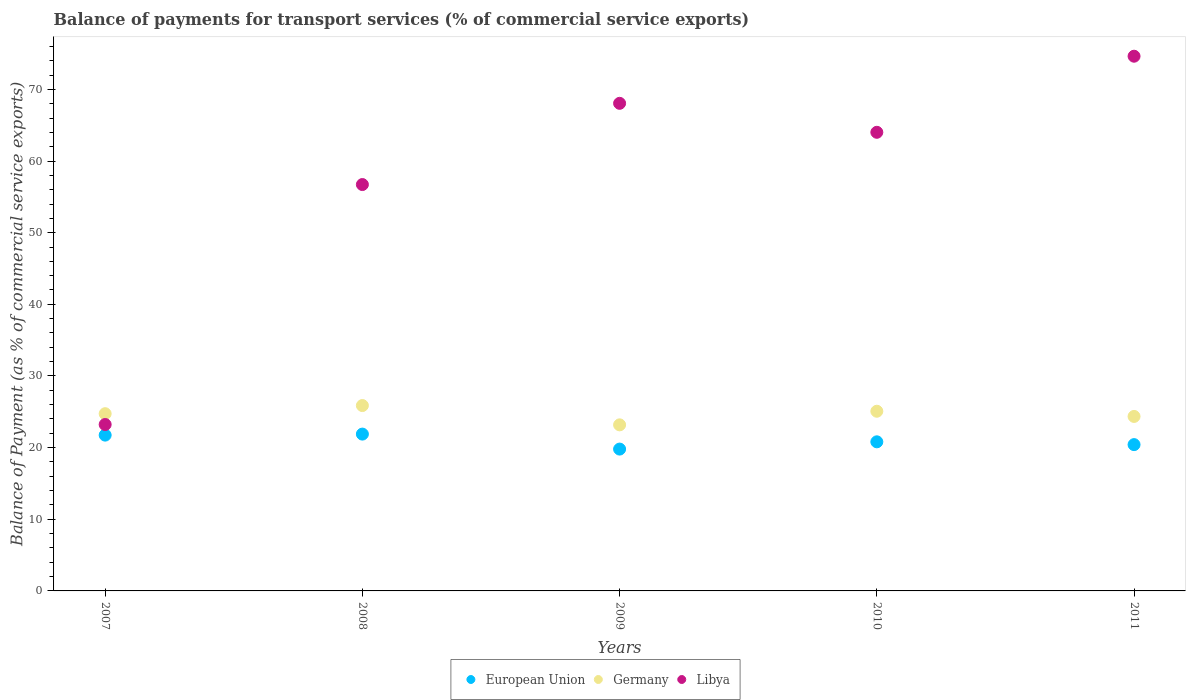How many different coloured dotlines are there?
Your answer should be very brief. 3. What is the balance of payments for transport services in European Union in 2009?
Keep it short and to the point. 19.8. Across all years, what is the maximum balance of payments for transport services in European Union?
Ensure brevity in your answer.  21.89. Across all years, what is the minimum balance of payments for transport services in Libya?
Your answer should be very brief. 23.23. In which year was the balance of payments for transport services in Libya maximum?
Provide a succinct answer. 2011. What is the total balance of payments for transport services in Germany in the graph?
Your answer should be very brief. 123.21. What is the difference between the balance of payments for transport services in European Union in 2010 and that in 2011?
Provide a short and direct response. 0.39. What is the difference between the balance of payments for transport services in European Union in 2007 and the balance of payments for transport services in Libya in 2008?
Your answer should be compact. -34.97. What is the average balance of payments for transport services in European Union per year?
Your answer should be compact. 20.93. In the year 2007, what is the difference between the balance of payments for transport services in Germany and balance of payments for transport services in Libya?
Ensure brevity in your answer.  1.51. In how many years, is the balance of payments for transport services in Libya greater than 12 %?
Make the answer very short. 5. What is the ratio of the balance of payments for transport services in Libya in 2007 to that in 2009?
Offer a terse response. 0.34. What is the difference between the highest and the second highest balance of payments for transport services in Germany?
Make the answer very short. 0.79. What is the difference between the highest and the lowest balance of payments for transport services in Libya?
Provide a short and direct response. 51.4. In how many years, is the balance of payments for transport services in European Union greater than the average balance of payments for transport services in European Union taken over all years?
Your answer should be compact. 2. Is the sum of the balance of payments for transport services in Germany in 2008 and 2009 greater than the maximum balance of payments for transport services in Libya across all years?
Provide a succinct answer. No. Is it the case that in every year, the sum of the balance of payments for transport services in Libya and balance of payments for transport services in Germany  is greater than the balance of payments for transport services in European Union?
Give a very brief answer. Yes. Is the balance of payments for transport services in European Union strictly greater than the balance of payments for transport services in Libya over the years?
Offer a terse response. No. How many years are there in the graph?
Keep it short and to the point. 5. Are the values on the major ticks of Y-axis written in scientific E-notation?
Offer a very short reply. No. How many legend labels are there?
Offer a very short reply. 3. What is the title of the graph?
Ensure brevity in your answer.  Balance of payments for transport services (% of commercial service exports). What is the label or title of the Y-axis?
Your answer should be very brief. Balance of Payment (as % of commercial service exports). What is the Balance of Payment (as % of commercial service exports) of European Union in 2007?
Offer a very short reply. 21.74. What is the Balance of Payment (as % of commercial service exports) in Germany in 2007?
Offer a terse response. 24.74. What is the Balance of Payment (as % of commercial service exports) of Libya in 2007?
Provide a succinct answer. 23.23. What is the Balance of Payment (as % of commercial service exports) of European Union in 2008?
Provide a short and direct response. 21.89. What is the Balance of Payment (as % of commercial service exports) in Germany in 2008?
Offer a very short reply. 25.87. What is the Balance of Payment (as % of commercial service exports) of Libya in 2008?
Your answer should be compact. 56.72. What is the Balance of Payment (as % of commercial service exports) of European Union in 2009?
Give a very brief answer. 19.8. What is the Balance of Payment (as % of commercial service exports) in Germany in 2009?
Give a very brief answer. 23.18. What is the Balance of Payment (as % of commercial service exports) of Libya in 2009?
Keep it short and to the point. 68.05. What is the Balance of Payment (as % of commercial service exports) in European Union in 2010?
Offer a terse response. 20.81. What is the Balance of Payment (as % of commercial service exports) of Germany in 2010?
Your answer should be very brief. 25.08. What is the Balance of Payment (as % of commercial service exports) of Libya in 2010?
Make the answer very short. 64.01. What is the Balance of Payment (as % of commercial service exports) in European Union in 2011?
Your answer should be very brief. 20.42. What is the Balance of Payment (as % of commercial service exports) of Germany in 2011?
Offer a very short reply. 24.35. What is the Balance of Payment (as % of commercial service exports) of Libya in 2011?
Give a very brief answer. 74.63. Across all years, what is the maximum Balance of Payment (as % of commercial service exports) of European Union?
Your answer should be very brief. 21.89. Across all years, what is the maximum Balance of Payment (as % of commercial service exports) of Germany?
Ensure brevity in your answer.  25.87. Across all years, what is the maximum Balance of Payment (as % of commercial service exports) in Libya?
Provide a short and direct response. 74.63. Across all years, what is the minimum Balance of Payment (as % of commercial service exports) of European Union?
Give a very brief answer. 19.8. Across all years, what is the minimum Balance of Payment (as % of commercial service exports) of Germany?
Give a very brief answer. 23.18. Across all years, what is the minimum Balance of Payment (as % of commercial service exports) in Libya?
Your response must be concise. 23.23. What is the total Balance of Payment (as % of commercial service exports) of European Union in the graph?
Your answer should be very brief. 104.66. What is the total Balance of Payment (as % of commercial service exports) in Germany in the graph?
Provide a short and direct response. 123.21. What is the total Balance of Payment (as % of commercial service exports) in Libya in the graph?
Your response must be concise. 286.63. What is the difference between the Balance of Payment (as % of commercial service exports) of European Union in 2007 and that in 2008?
Provide a short and direct response. -0.14. What is the difference between the Balance of Payment (as % of commercial service exports) in Germany in 2007 and that in 2008?
Provide a succinct answer. -1.13. What is the difference between the Balance of Payment (as % of commercial service exports) in Libya in 2007 and that in 2008?
Offer a very short reply. -33.49. What is the difference between the Balance of Payment (as % of commercial service exports) in European Union in 2007 and that in 2009?
Offer a terse response. 1.95. What is the difference between the Balance of Payment (as % of commercial service exports) in Germany in 2007 and that in 2009?
Keep it short and to the point. 1.56. What is the difference between the Balance of Payment (as % of commercial service exports) in Libya in 2007 and that in 2009?
Your answer should be very brief. -44.83. What is the difference between the Balance of Payment (as % of commercial service exports) of European Union in 2007 and that in 2010?
Your answer should be compact. 0.93. What is the difference between the Balance of Payment (as % of commercial service exports) in Germany in 2007 and that in 2010?
Provide a short and direct response. -0.34. What is the difference between the Balance of Payment (as % of commercial service exports) in Libya in 2007 and that in 2010?
Keep it short and to the point. -40.78. What is the difference between the Balance of Payment (as % of commercial service exports) of European Union in 2007 and that in 2011?
Offer a very short reply. 1.33. What is the difference between the Balance of Payment (as % of commercial service exports) in Germany in 2007 and that in 2011?
Your answer should be compact. 0.38. What is the difference between the Balance of Payment (as % of commercial service exports) in Libya in 2007 and that in 2011?
Keep it short and to the point. -51.4. What is the difference between the Balance of Payment (as % of commercial service exports) in European Union in 2008 and that in 2009?
Give a very brief answer. 2.09. What is the difference between the Balance of Payment (as % of commercial service exports) of Germany in 2008 and that in 2009?
Ensure brevity in your answer.  2.69. What is the difference between the Balance of Payment (as % of commercial service exports) of Libya in 2008 and that in 2009?
Provide a succinct answer. -11.34. What is the difference between the Balance of Payment (as % of commercial service exports) of European Union in 2008 and that in 2010?
Keep it short and to the point. 1.08. What is the difference between the Balance of Payment (as % of commercial service exports) of Germany in 2008 and that in 2010?
Make the answer very short. 0.79. What is the difference between the Balance of Payment (as % of commercial service exports) of Libya in 2008 and that in 2010?
Keep it short and to the point. -7.29. What is the difference between the Balance of Payment (as % of commercial service exports) of European Union in 2008 and that in 2011?
Your answer should be compact. 1.47. What is the difference between the Balance of Payment (as % of commercial service exports) in Germany in 2008 and that in 2011?
Offer a terse response. 1.52. What is the difference between the Balance of Payment (as % of commercial service exports) of Libya in 2008 and that in 2011?
Your answer should be very brief. -17.91. What is the difference between the Balance of Payment (as % of commercial service exports) in European Union in 2009 and that in 2010?
Your response must be concise. -1.01. What is the difference between the Balance of Payment (as % of commercial service exports) in Germany in 2009 and that in 2010?
Your answer should be very brief. -1.9. What is the difference between the Balance of Payment (as % of commercial service exports) in Libya in 2009 and that in 2010?
Give a very brief answer. 4.04. What is the difference between the Balance of Payment (as % of commercial service exports) of European Union in 2009 and that in 2011?
Your answer should be very brief. -0.62. What is the difference between the Balance of Payment (as % of commercial service exports) in Germany in 2009 and that in 2011?
Give a very brief answer. -1.17. What is the difference between the Balance of Payment (as % of commercial service exports) in Libya in 2009 and that in 2011?
Offer a terse response. -6.57. What is the difference between the Balance of Payment (as % of commercial service exports) of European Union in 2010 and that in 2011?
Offer a very short reply. 0.39. What is the difference between the Balance of Payment (as % of commercial service exports) of Germany in 2010 and that in 2011?
Your answer should be very brief. 0.72. What is the difference between the Balance of Payment (as % of commercial service exports) in Libya in 2010 and that in 2011?
Offer a terse response. -10.62. What is the difference between the Balance of Payment (as % of commercial service exports) in European Union in 2007 and the Balance of Payment (as % of commercial service exports) in Germany in 2008?
Your response must be concise. -4.13. What is the difference between the Balance of Payment (as % of commercial service exports) in European Union in 2007 and the Balance of Payment (as % of commercial service exports) in Libya in 2008?
Offer a terse response. -34.97. What is the difference between the Balance of Payment (as % of commercial service exports) in Germany in 2007 and the Balance of Payment (as % of commercial service exports) in Libya in 2008?
Provide a succinct answer. -31.98. What is the difference between the Balance of Payment (as % of commercial service exports) of European Union in 2007 and the Balance of Payment (as % of commercial service exports) of Germany in 2009?
Offer a very short reply. -1.43. What is the difference between the Balance of Payment (as % of commercial service exports) of European Union in 2007 and the Balance of Payment (as % of commercial service exports) of Libya in 2009?
Your response must be concise. -46.31. What is the difference between the Balance of Payment (as % of commercial service exports) in Germany in 2007 and the Balance of Payment (as % of commercial service exports) in Libya in 2009?
Keep it short and to the point. -43.32. What is the difference between the Balance of Payment (as % of commercial service exports) in European Union in 2007 and the Balance of Payment (as % of commercial service exports) in Germany in 2010?
Your response must be concise. -3.33. What is the difference between the Balance of Payment (as % of commercial service exports) in European Union in 2007 and the Balance of Payment (as % of commercial service exports) in Libya in 2010?
Provide a succinct answer. -42.26. What is the difference between the Balance of Payment (as % of commercial service exports) in Germany in 2007 and the Balance of Payment (as % of commercial service exports) in Libya in 2010?
Your answer should be compact. -39.27. What is the difference between the Balance of Payment (as % of commercial service exports) in European Union in 2007 and the Balance of Payment (as % of commercial service exports) in Germany in 2011?
Provide a short and direct response. -2.61. What is the difference between the Balance of Payment (as % of commercial service exports) of European Union in 2007 and the Balance of Payment (as % of commercial service exports) of Libya in 2011?
Your answer should be very brief. -52.88. What is the difference between the Balance of Payment (as % of commercial service exports) in Germany in 2007 and the Balance of Payment (as % of commercial service exports) in Libya in 2011?
Your answer should be very brief. -49.89. What is the difference between the Balance of Payment (as % of commercial service exports) in European Union in 2008 and the Balance of Payment (as % of commercial service exports) in Germany in 2009?
Offer a terse response. -1.29. What is the difference between the Balance of Payment (as % of commercial service exports) of European Union in 2008 and the Balance of Payment (as % of commercial service exports) of Libya in 2009?
Your answer should be very brief. -46.16. What is the difference between the Balance of Payment (as % of commercial service exports) of Germany in 2008 and the Balance of Payment (as % of commercial service exports) of Libya in 2009?
Your answer should be compact. -42.18. What is the difference between the Balance of Payment (as % of commercial service exports) in European Union in 2008 and the Balance of Payment (as % of commercial service exports) in Germany in 2010?
Your response must be concise. -3.19. What is the difference between the Balance of Payment (as % of commercial service exports) of European Union in 2008 and the Balance of Payment (as % of commercial service exports) of Libya in 2010?
Your answer should be very brief. -42.12. What is the difference between the Balance of Payment (as % of commercial service exports) of Germany in 2008 and the Balance of Payment (as % of commercial service exports) of Libya in 2010?
Provide a succinct answer. -38.14. What is the difference between the Balance of Payment (as % of commercial service exports) of European Union in 2008 and the Balance of Payment (as % of commercial service exports) of Germany in 2011?
Your answer should be compact. -2.47. What is the difference between the Balance of Payment (as % of commercial service exports) in European Union in 2008 and the Balance of Payment (as % of commercial service exports) in Libya in 2011?
Keep it short and to the point. -52.74. What is the difference between the Balance of Payment (as % of commercial service exports) in Germany in 2008 and the Balance of Payment (as % of commercial service exports) in Libya in 2011?
Your answer should be very brief. -48.76. What is the difference between the Balance of Payment (as % of commercial service exports) of European Union in 2009 and the Balance of Payment (as % of commercial service exports) of Germany in 2010?
Your answer should be very brief. -5.28. What is the difference between the Balance of Payment (as % of commercial service exports) of European Union in 2009 and the Balance of Payment (as % of commercial service exports) of Libya in 2010?
Provide a short and direct response. -44.21. What is the difference between the Balance of Payment (as % of commercial service exports) of Germany in 2009 and the Balance of Payment (as % of commercial service exports) of Libya in 2010?
Your answer should be very brief. -40.83. What is the difference between the Balance of Payment (as % of commercial service exports) in European Union in 2009 and the Balance of Payment (as % of commercial service exports) in Germany in 2011?
Ensure brevity in your answer.  -4.56. What is the difference between the Balance of Payment (as % of commercial service exports) of European Union in 2009 and the Balance of Payment (as % of commercial service exports) of Libya in 2011?
Provide a short and direct response. -54.83. What is the difference between the Balance of Payment (as % of commercial service exports) in Germany in 2009 and the Balance of Payment (as % of commercial service exports) in Libya in 2011?
Your response must be concise. -51.45. What is the difference between the Balance of Payment (as % of commercial service exports) in European Union in 2010 and the Balance of Payment (as % of commercial service exports) in Germany in 2011?
Offer a terse response. -3.54. What is the difference between the Balance of Payment (as % of commercial service exports) of European Union in 2010 and the Balance of Payment (as % of commercial service exports) of Libya in 2011?
Provide a short and direct response. -53.82. What is the difference between the Balance of Payment (as % of commercial service exports) in Germany in 2010 and the Balance of Payment (as % of commercial service exports) in Libya in 2011?
Provide a succinct answer. -49.55. What is the average Balance of Payment (as % of commercial service exports) in European Union per year?
Offer a very short reply. 20.93. What is the average Balance of Payment (as % of commercial service exports) of Germany per year?
Provide a short and direct response. 24.64. What is the average Balance of Payment (as % of commercial service exports) of Libya per year?
Give a very brief answer. 57.33. In the year 2007, what is the difference between the Balance of Payment (as % of commercial service exports) of European Union and Balance of Payment (as % of commercial service exports) of Germany?
Your answer should be compact. -2.99. In the year 2007, what is the difference between the Balance of Payment (as % of commercial service exports) in European Union and Balance of Payment (as % of commercial service exports) in Libya?
Offer a very short reply. -1.48. In the year 2007, what is the difference between the Balance of Payment (as % of commercial service exports) of Germany and Balance of Payment (as % of commercial service exports) of Libya?
Keep it short and to the point. 1.51. In the year 2008, what is the difference between the Balance of Payment (as % of commercial service exports) of European Union and Balance of Payment (as % of commercial service exports) of Germany?
Provide a succinct answer. -3.98. In the year 2008, what is the difference between the Balance of Payment (as % of commercial service exports) of European Union and Balance of Payment (as % of commercial service exports) of Libya?
Offer a very short reply. -34.83. In the year 2008, what is the difference between the Balance of Payment (as % of commercial service exports) in Germany and Balance of Payment (as % of commercial service exports) in Libya?
Your answer should be very brief. -30.85. In the year 2009, what is the difference between the Balance of Payment (as % of commercial service exports) of European Union and Balance of Payment (as % of commercial service exports) of Germany?
Keep it short and to the point. -3.38. In the year 2009, what is the difference between the Balance of Payment (as % of commercial service exports) in European Union and Balance of Payment (as % of commercial service exports) in Libya?
Your answer should be compact. -48.26. In the year 2009, what is the difference between the Balance of Payment (as % of commercial service exports) in Germany and Balance of Payment (as % of commercial service exports) in Libya?
Keep it short and to the point. -44.87. In the year 2010, what is the difference between the Balance of Payment (as % of commercial service exports) of European Union and Balance of Payment (as % of commercial service exports) of Germany?
Make the answer very short. -4.27. In the year 2010, what is the difference between the Balance of Payment (as % of commercial service exports) of European Union and Balance of Payment (as % of commercial service exports) of Libya?
Offer a terse response. -43.2. In the year 2010, what is the difference between the Balance of Payment (as % of commercial service exports) of Germany and Balance of Payment (as % of commercial service exports) of Libya?
Provide a succinct answer. -38.93. In the year 2011, what is the difference between the Balance of Payment (as % of commercial service exports) in European Union and Balance of Payment (as % of commercial service exports) in Germany?
Ensure brevity in your answer.  -3.93. In the year 2011, what is the difference between the Balance of Payment (as % of commercial service exports) in European Union and Balance of Payment (as % of commercial service exports) in Libya?
Your response must be concise. -54.21. In the year 2011, what is the difference between the Balance of Payment (as % of commercial service exports) of Germany and Balance of Payment (as % of commercial service exports) of Libya?
Provide a short and direct response. -50.27. What is the ratio of the Balance of Payment (as % of commercial service exports) in Germany in 2007 to that in 2008?
Give a very brief answer. 0.96. What is the ratio of the Balance of Payment (as % of commercial service exports) in Libya in 2007 to that in 2008?
Provide a succinct answer. 0.41. What is the ratio of the Balance of Payment (as % of commercial service exports) in European Union in 2007 to that in 2009?
Provide a short and direct response. 1.1. What is the ratio of the Balance of Payment (as % of commercial service exports) in Germany in 2007 to that in 2009?
Give a very brief answer. 1.07. What is the ratio of the Balance of Payment (as % of commercial service exports) of Libya in 2007 to that in 2009?
Provide a short and direct response. 0.34. What is the ratio of the Balance of Payment (as % of commercial service exports) in European Union in 2007 to that in 2010?
Ensure brevity in your answer.  1.04. What is the ratio of the Balance of Payment (as % of commercial service exports) in Germany in 2007 to that in 2010?
Your response must be concise. 0.99. What is the ratio of the Balance of Payment (as % of commercial service exports) in Libya in 2007 to that in 2010?
Offer a terse response. 0.36. What is the ratio of the Balance of Payment (as % of commercial service exports) of European Union in 2007 to that in 2011?
Keep it short and to the point. 1.06. What is the ratio of the Balance of Payment (as % of commercial service exports) of Germany in 2007 to that in 2011?
Offer a terse response. 1.02. What is the ratio of the Balance of Payment (as % of commercial service exports) of Libya in 2007 to that in 2011?
Provide a succinct answer. 0.31. What is the ratio of the Balance of Payment (as % of commercial service exports) in European Union in 2008 to that in 2009?
Provide a short and direct response. 1.11. What is the ratio of the Balance of Payment (as % of commercial service exports) in Germany in 2008 to that in 2009?
Provide a succinct answer. 1.12. What is the ratio of the Balance of Payment (as % of commercial service exports) of Libya in 2008 to that in 2009?
Keep it short and to the point. 0.83. What is the ratio of the Balance of Payment (as % of commercial service exports) in European Union in 2008 to that in 2010?
Your response must be concise. 1.05. What is the ratio of the Balance of Payment (as % of commercial service exports) in Germany in 2008 to that in 2010?
Your answer should be compact. 1.03. What is the ratio of the Balance of Payment (as % of commercial service exports) in Libya in 2008 to that in 2010?
Your answer should be compact. 0.89. What is the ratio of the Balance of Payment (as % of commercial service exports) in European Union in 2008 to that in 2011?
Your answer should be compact. 1.07. What is the ratio of the Balance of Payment (as % of commercial service exports) of Germany in 2008 to that in 2011?
Offer a very short reply. 1.06. What is the ratio of the Balance of Payment (as % of commercial service exports) in Libya in 2008 to that in 2011?
Provide a succinct answer. 0.76. What is the ratio of the Balance of Payment (as % of commercial service exports) in European Union in 2009 to that in 2010?
Your answer should be very brief. 0.95. What is the ratio of the Balance of Payment (as % of commercial service exports) in Germany in 2009 to that in 2010?
Offer a terse response. 0.92. What is the ratio of the Balance of Payment (as % of commercial service exports) of Libya in 2009 to that in 2010?
Provide a succinct answer. 1.06. What is the ratio of the Balance of Payment (as % of commercial service exports) in European Union in 2009 to that in 2011?
Your response must be concise. 0.97. What is the ratio of the Balance of Payment (as % of commercial service exports) in Germany in 2009 to that in 2011?
Ensure brevity in your answer.  0.95. What is the ratio of the Balance of Payment (as % of commercial service exports) in Libya in 2009 to that in 2011?
Make the answer very short. 0.91. What is the ratio of the Balance of Payment (as % of commercial service exports) in European Union in 2010 to that in 2011?
Provide a succinct answer. 1.02. What is the ratio of the Balance of Payment (as % of commercial service exports) of Germany in 2010 to that in 2011?
Offer a terse response. 1.03. What is the ratio of the Balance of Payment (as % of commercial service exports) in Libya in 2010 to that in 2011?
Make the answer very short. 0.86. What is the difference between the highest and the second highest Balance of Payment (as % of commercial service exports) in European Union?
Provide a succinct answer. 0.14. What is the difference between the highest and the second highest Balance of Payment (as % of commercial service exports) of Germany?
Offer a very short reply. 0.79. What is the difference between the highest and the second highest Balance of Payment (as % of commercial service exports) in Libya?
Provide a short and direct response. 6.57. What is the difference between the highest and the lowest Balance of Payment (as % of commercial service exports) of European Union?
Make the answer very short. 2.09. What is the difference between the highest and the lowest Balance of Payment (as % of commercial service exports) of Germany?
Your response must be concise. 2.69. What is the difference between the highest and the lowest Balance of Payment (as % of commercial service exports) in Libya?
Provide a short and direct response. 51.4. 